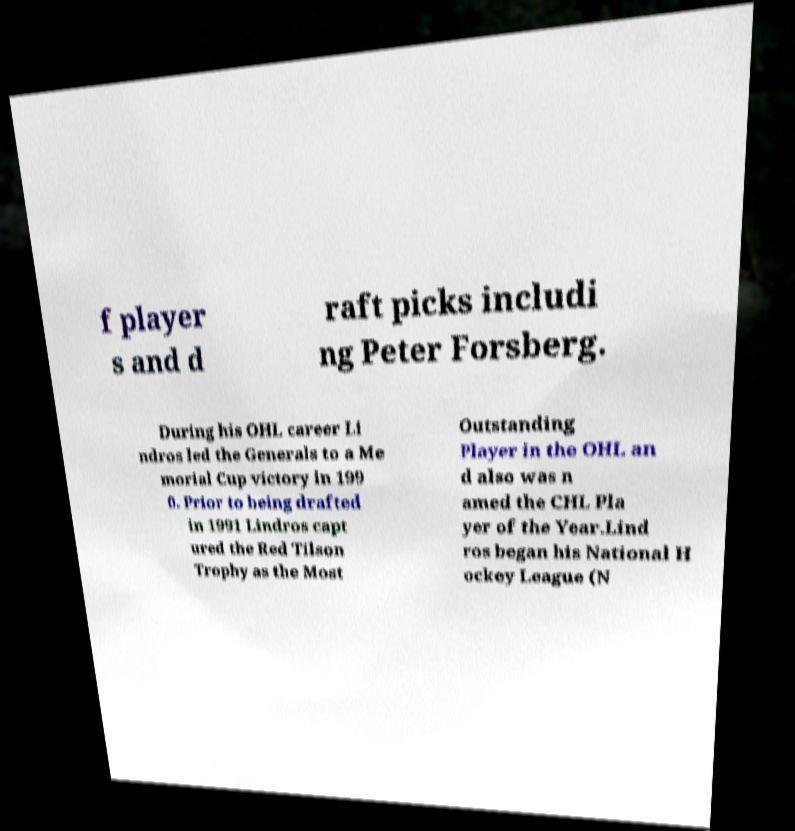Could you assist in decoding the text presented in this image and type it out clearly? f player s and d raft picks includi ng Peter Forsberg. During his OHL career Li ndros led the Generals to a Me morial Cup victory in 199 0. Prior to being drafted in 1991 Lindros capt ured the Red Tilson Trophy as the Most Outstanding Player in the OHL an d also was n amed the CHL Pla yer of the Year.Lind ros began his National H ockey League (N 